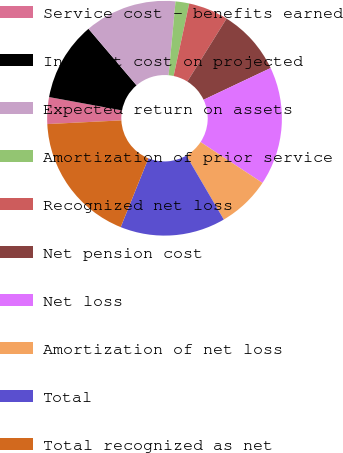Convert chart. <chart><loc_0><loc_0><loc_500><loc_500><pie_chart><fcel>Service cost - benefits earned<fcel>Interest cost on projected<fcel>Expected return on assets<fcel>Amortization of prior service<fcel>Recognized net loss<fcel>Net pension cost<fcel>Net loss<fcel>Amortization of net loss<fcel>Total<fcel>Total recognized as net<nl><fcel>3.68%<fcel>10.9%<fcel>12.71%<fcel>1.88%<fcel>5.49%<fcel>9.1%<fcel>16.32%<fcel>7.29%<fcel>14.51%<fcel>18.12%<nl></chart> 